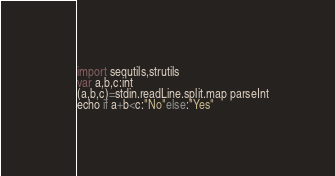Convert code to text. <code><loc_0><loc_0><loc_500><loc_500><_Nim_>import sequtils,strutils
var a,b,c:int
(a,b,c)=stdin.readLine.split.map parseInt
echo if a+b<c:"No"else:"Yes"</code> 